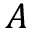<formula> <loc_0><loc_0><loc_500><loc_500>A</formula> 